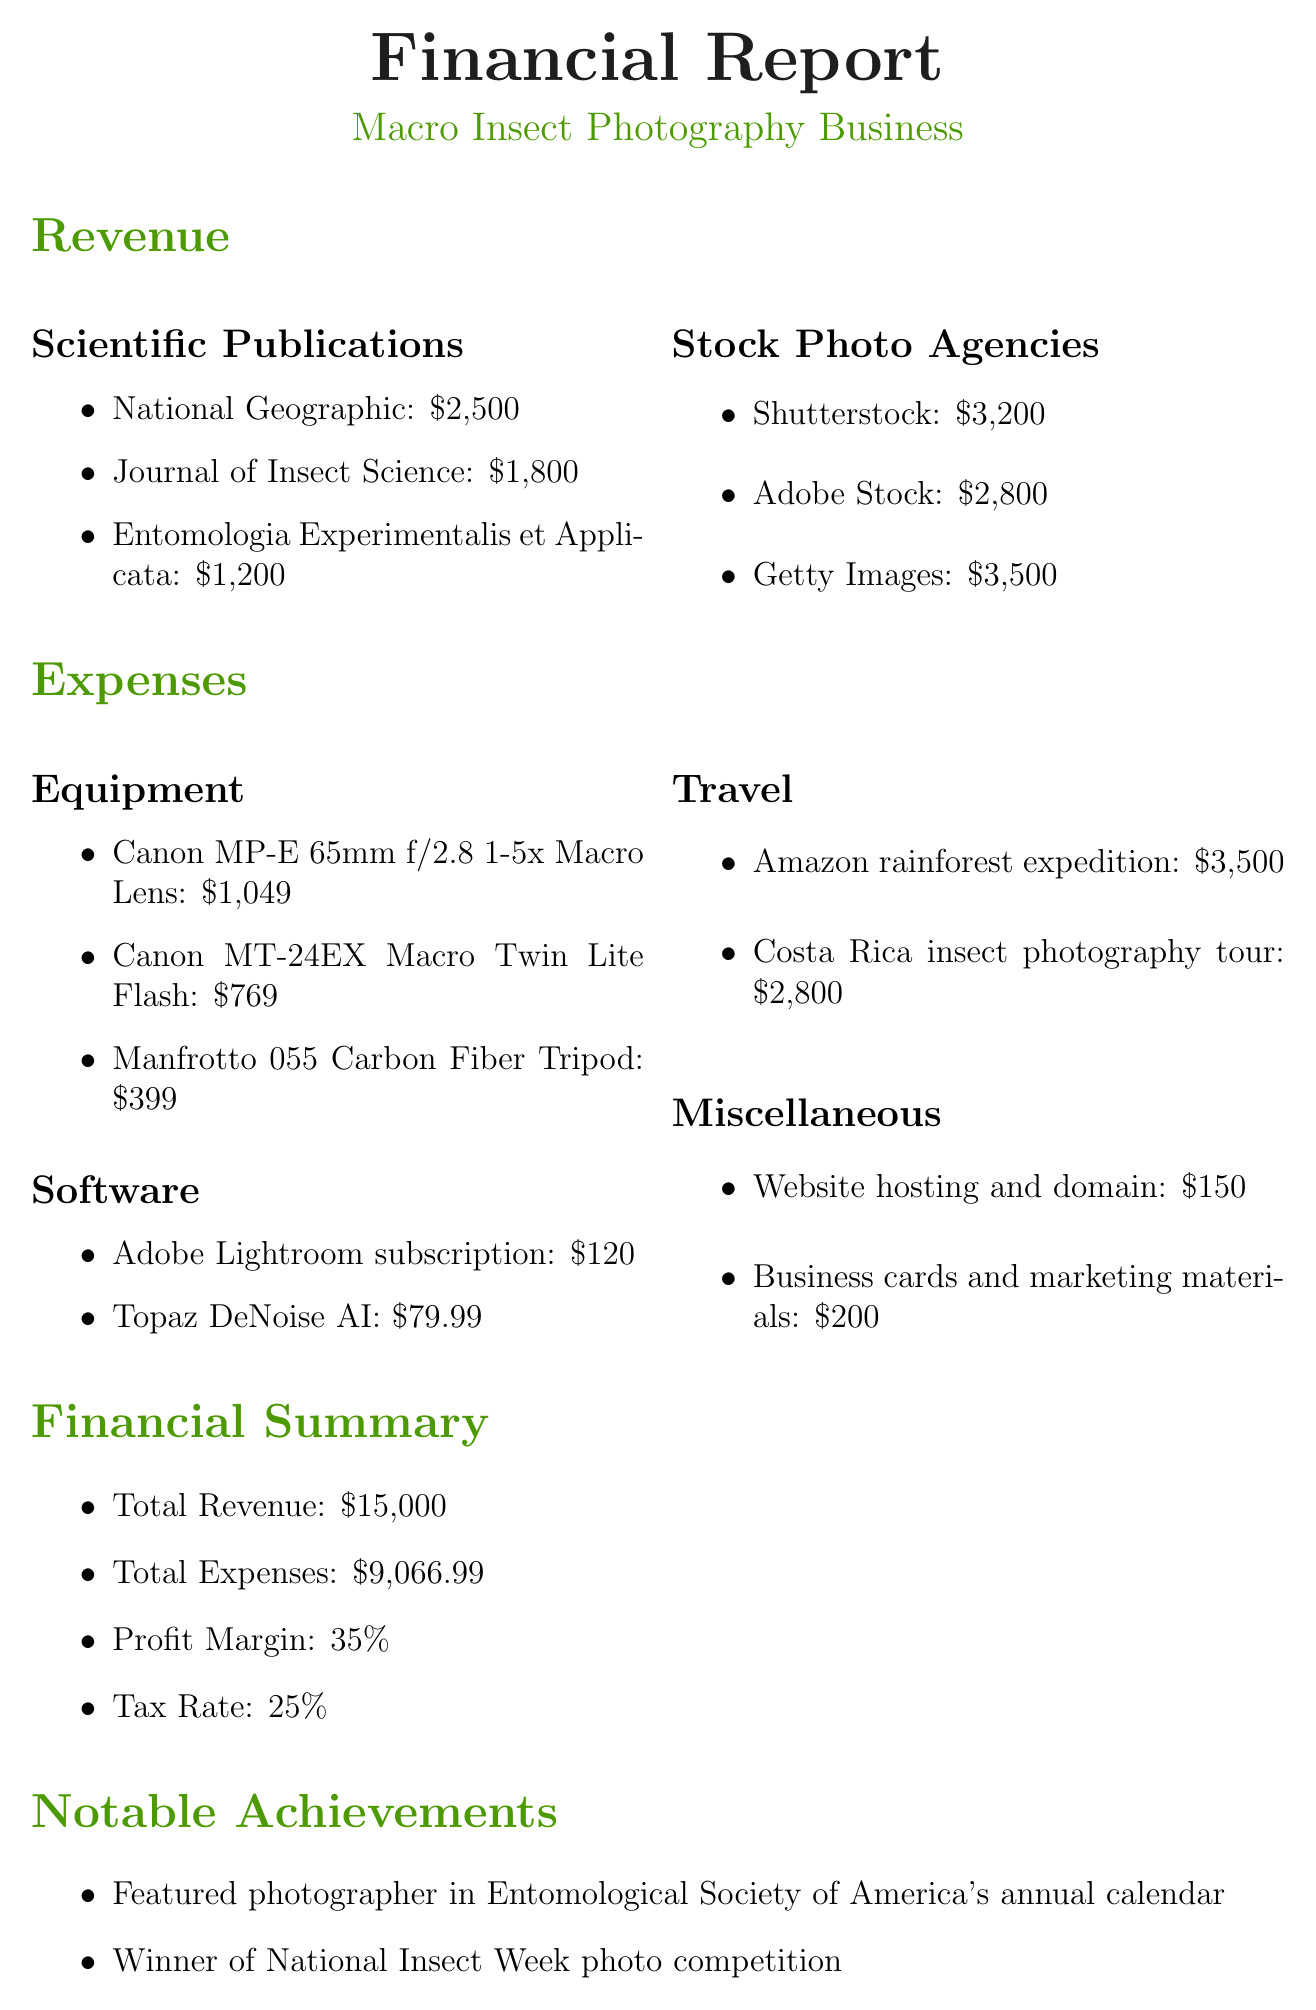What is the total revenue? The total revenue is the sum of all revenue sources in the document, which is $2500 + $1800 + $1200 + $3200 + $2800 + $3500 = $15000.
Answer: $15000 What is the profit margin? The profit margin is explicitly stated in the document as 35%.
Answer: 35% What was the expense for the Canon MP-E 65mm f/2.8 1-5x Macro Lens? The expense for this equipment is mentioned in the document as $1049.
Answer: $1049 Which stock photo agency generated the highest revenue? The document lists Getty Images as the stock photo agency with the highest revenue of $3500.
Answer: Getty Images What is the total expense amount? The total expenses are calculated by summing all listed expenses, which amounts to $9066.99.
Answer: $9066.99 Which achievement is noted in the document? The document highlights being a featured photographer in the Entomological Society of America's annual calendar as one notable achievement.
Answer: Featured photographer in Entomological Society of America's annual calendar What is the tax rate? The tax rate is clearly stated in the document as 25%.
Answer: 25% What is the expected revenue growth? The expected revenue growth is mentioned explicitly in the document as 15%.
Answer: 15% What is one planned investment for the future? The document mentions the Focus stacking rail system as a planned investment of $500.
Answer: Focus stacking rail system 